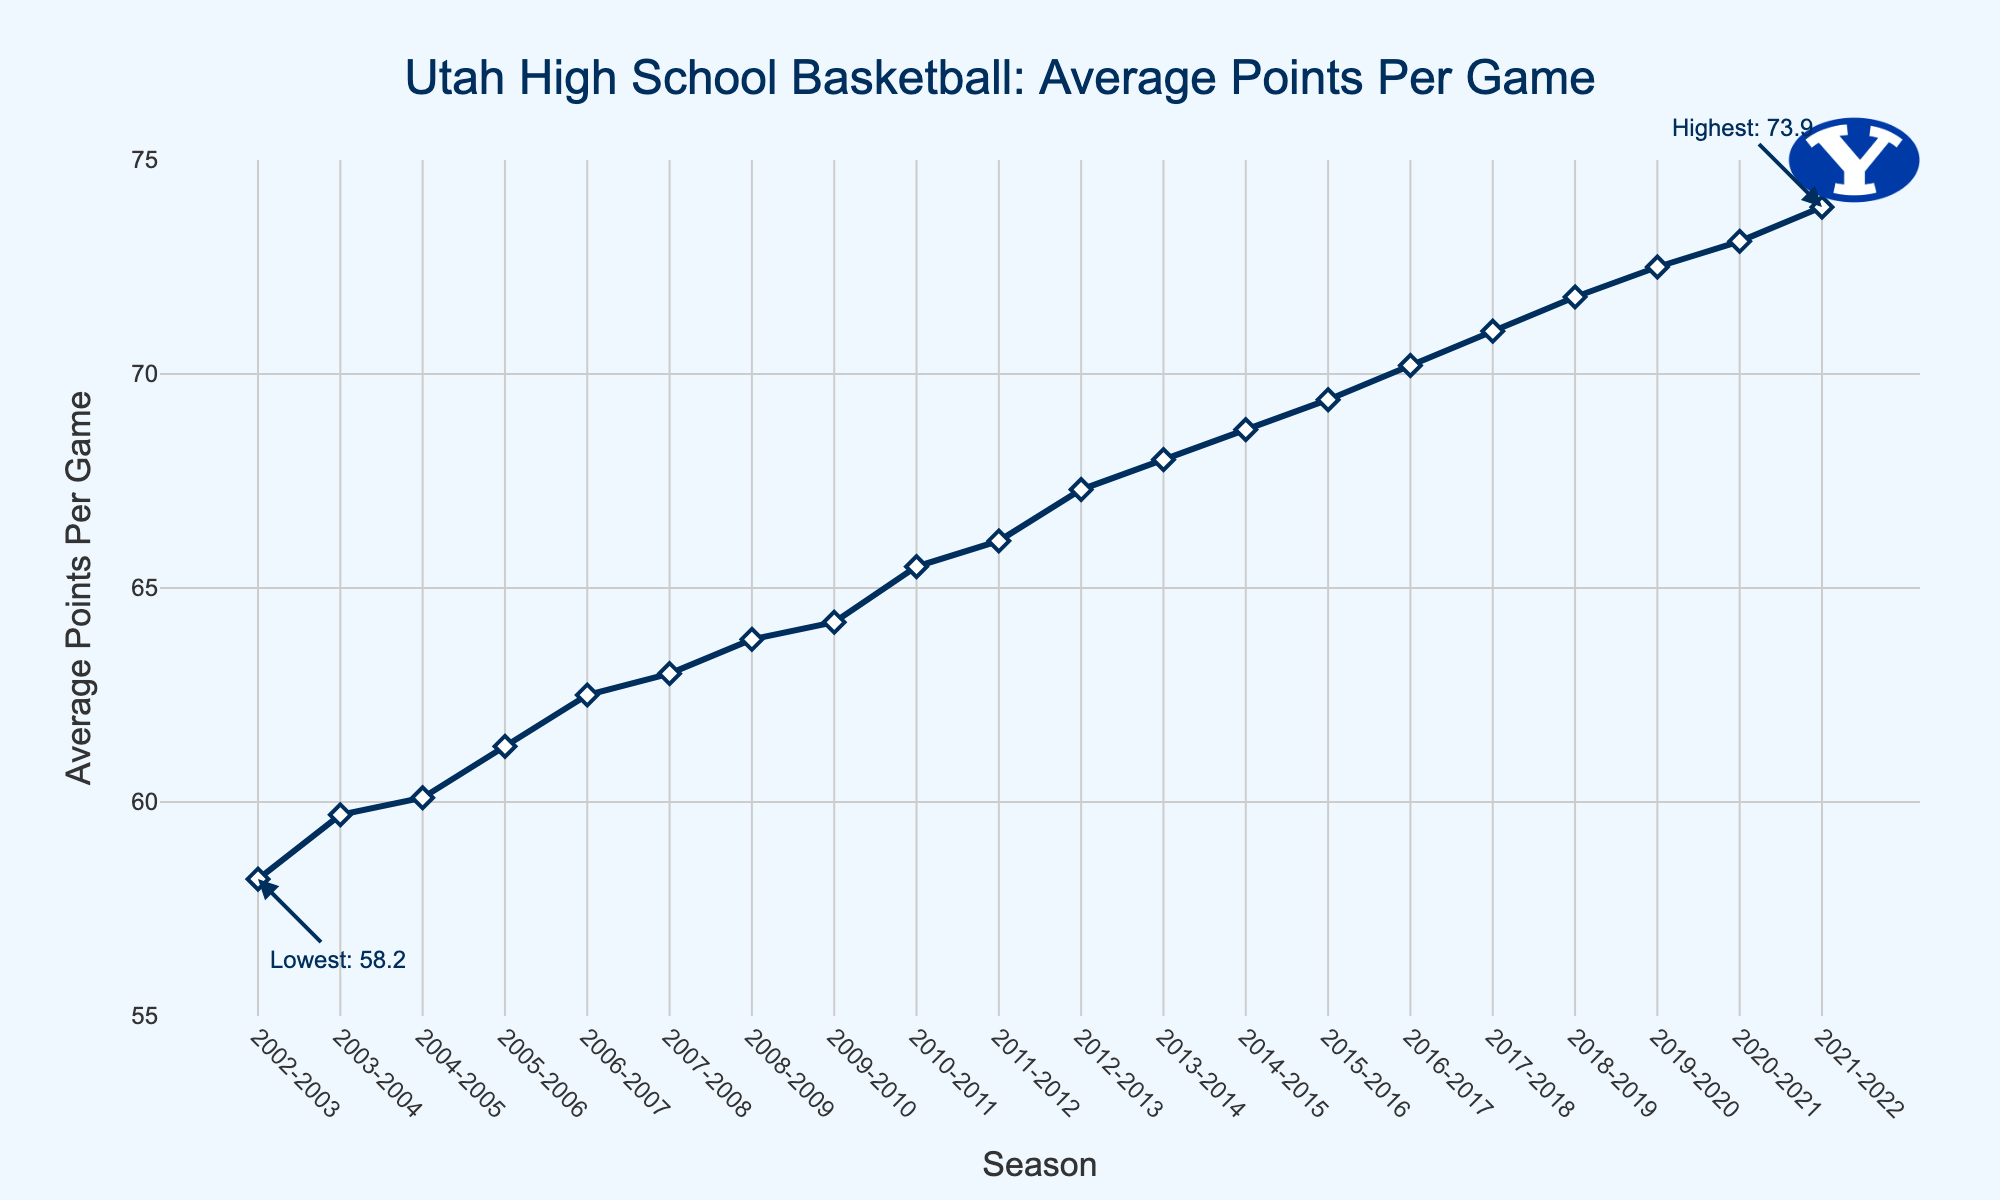What season had the highest average points per game? The annotation on the figure indicates "Highest: 73.9" next to the 2021-2022 season.
Answer: 2021-2022 What season had the lowest average points per game? The annotation on the figure indicates "Lowest: 58.2" next to the 2002-2003 season.
Answer: 2002-2003 How much did the average points per game increase from the 2002-2003 season to the 2021-2022 season? Subtract the average points of the 2002-2003 season from the average points of the 2021-2022 season: 73.9 - 58.2 = 15.7.
Answer: 15.7 What is the average increase in points per game per season from 2002-2003 to 2021-2022? Compute the difference in points between 2021-2022 and 2002-2003, then divide by the number of seasons minus one: (73.9 - 58.2) / 19 = 0.8263.
Answer: 0.8263 Which season showed the most significant increase in average points per game compared to the previous season? Evaluate the difference between adjacent seasons in the chart. The maximum increase occurred from 2001-2002 (72.5) to 2021-2022 (73.1), with an increase of 0.6 points.
Answer: 2020-2021 to 2021-2022 In which range (58 to 75) have most of the average points per game fallen in the past 20 seasons? By visually inspecting the plot, most of the data points lie in the range from 60 to 73.
Answer: 60 to 73 How many seasons had an average points per game above 70? Count the number of seasons with average points per game values above 70 starting from 2016-2017 to 2021-2022.
Answer: 6 Between which seasons did the average points per game first surpass 65? The figure shows the increase surpassing 65 between the 2009-2010 and 2010-2011 seasons.
Answer: 2009-2010 to 2010-2011 What is the sum of the average points per game for the first five seasons? Add the average points for 2002-2003 to 2006-2007: 58.2 + 59.7 + 60.1 + 61.3 + 62.5 = 301.8.
Answer: 301.8 Compare the average points per game in the 2010-2011 and 2015-2016 seasons. Which is higher? The figure shows 2010-2011 with 65.5 points and 2015-2016 with 69.4 points. Thus, 2015-2016 is higher.
Answer: 2015-2016 